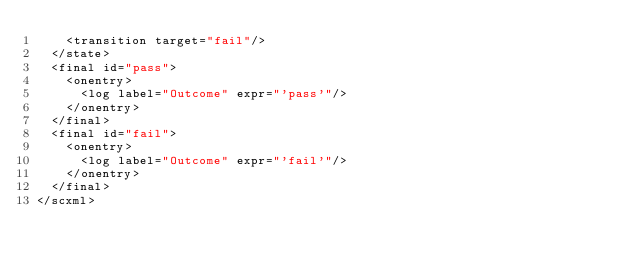<code> <loc_0><loc_0><loc_500><loc_500><_XML_>    <transition target="fail"/>
  </state>
  <final id="pass">
    <onentry>
      <log label="Outcome" expr="'pass'"/>
    </onentry>
  </final>
  <final id="fail">
    <onentry>
      <log label="Outcome" expr="'fail'"/>
    </onentry>
  </final>
</scxml>
</code> 